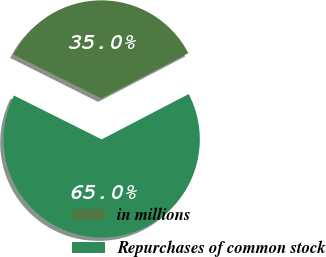Convert chart. <chart><loc_0><loc_0><loc_500><loc_500><pie_chart><fcel>in millions<fcel>Repurchases of common stock<nl><fcel>34.97%<fcel>65.03%<nl></chart> 